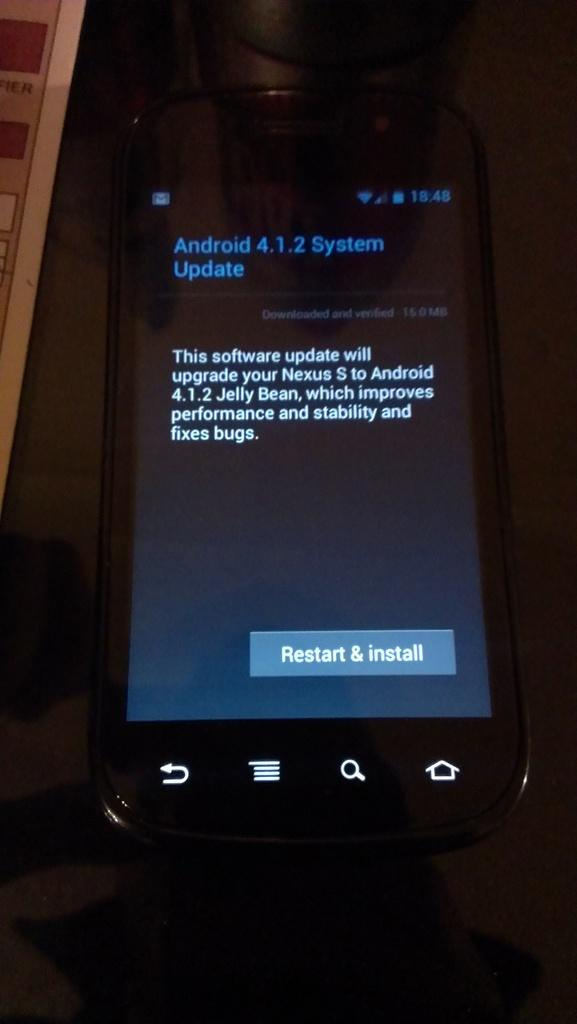<image>
Summarize the visual content of the image. A cellphone undergoing a system update in Android 4.1.2. 